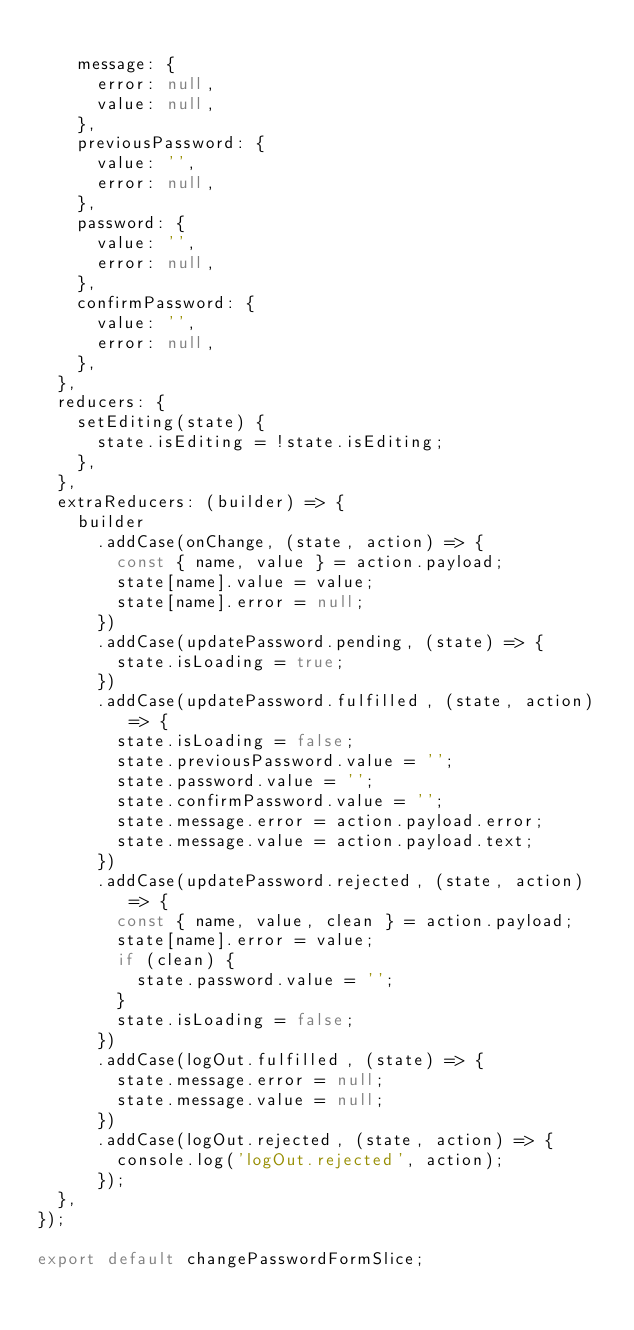<code> <loc_0><loc_0><loc_500><loc_500><_JavaScript_>
    message: {
      error: null,
      value: null,
    },
    previousPassword: {
      value: '',
      error: null,
    },
    password: {
      value: '',
      error: null,
    },
    confirmPassword: {
      value: '',
      error: null,
    },
  },
  reducers: {
    setEditing(state) {
      state.isEditing = !state.isEditing;
    },
  },
  extraReducers: (builder) => {
    builder
      .addCase(onChange, (state, action) => {
        const { name, value } = action.payload;
        state[name].value = value;
        state[name].error = null;
      })
      .addCase(updatePassword.pending, (state) => {
        state.isLoading = true;
      })
      .addCase(updatePassword.fulfilled, (state, action) => {
        state.isLoading = false;
        state.previousPassword.value = '';
        state.password.value = '';
        state.confirmPassword.value = '';
        state.message.error = action.payload.error;
        state.message.value = action.payload.text;
      })
      .addCase(updatePassword.rejected, (state, action) => {
        const { name, value, clean } = action.payload;
        state[name].error = value;
        if (clean) {
          state.password.value = '';
        }
        state.isLoading = false;
      })
      .addCase(logOut.fulfilled, (state) => {
        state.message.error = null;
        state.message.value = null;
      })
      .addCase(logOut.rejected, (state, action) => {
        console.log('logOut.rejected', action);
      });
  },
});

export default changePasswordFormSlice;
</code> 